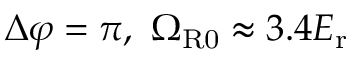Convert formula to latex. <formula><loc_0><loc_0><loc_500><loc_500>\Delta \varphi = \pi , \Omega _ { R 0 } \approx 3 . 4 E _ { r }</formula> 